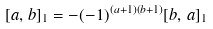<formula> <loc_0><loc_0><loc_500><loc_500>[ a , \, b ] _ { 1 } = - ( - 1 ) ^ { ( a + 1 ) ( b + 1 ) } [ b , \, a ] _ { 1 }</formula> 